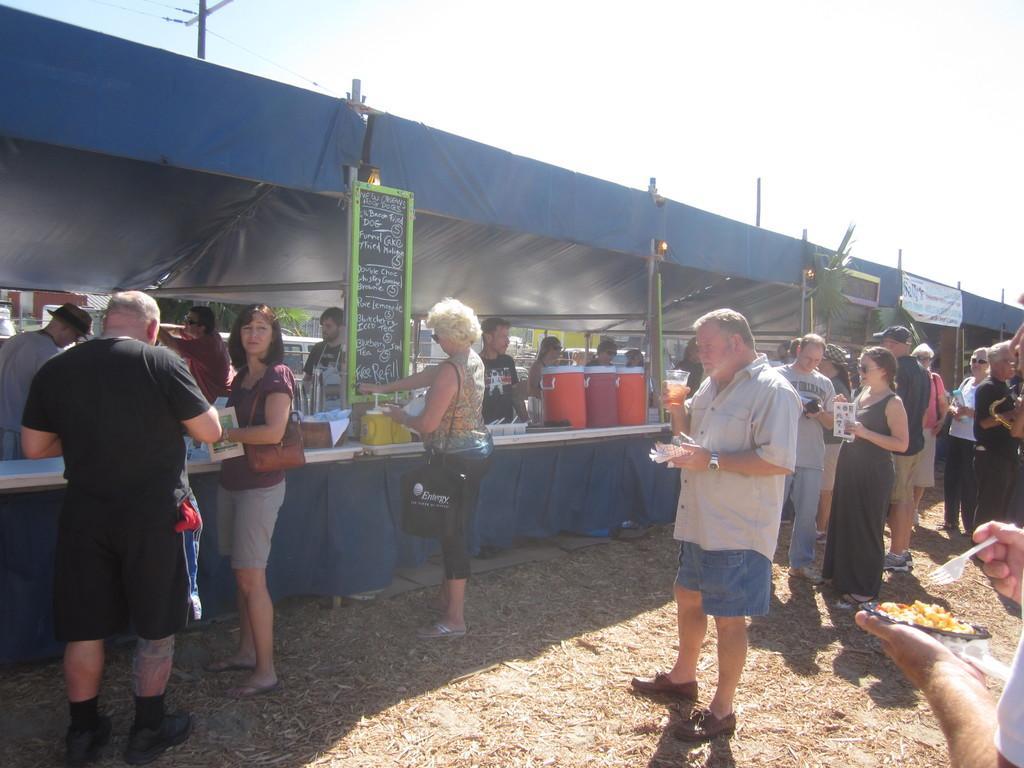Describe this image in one or two sentences. In this image I see number of people in which this man is holding a glass in one hand and another thing in other hand and this person is holding a plate in which there is food in one hand and a fork in other hand and I see the board over here on which something is written and I see the tables over here on which there are many things and I see the lights and I see the banner over here. In the background I see the sky and I see a pole over here. 